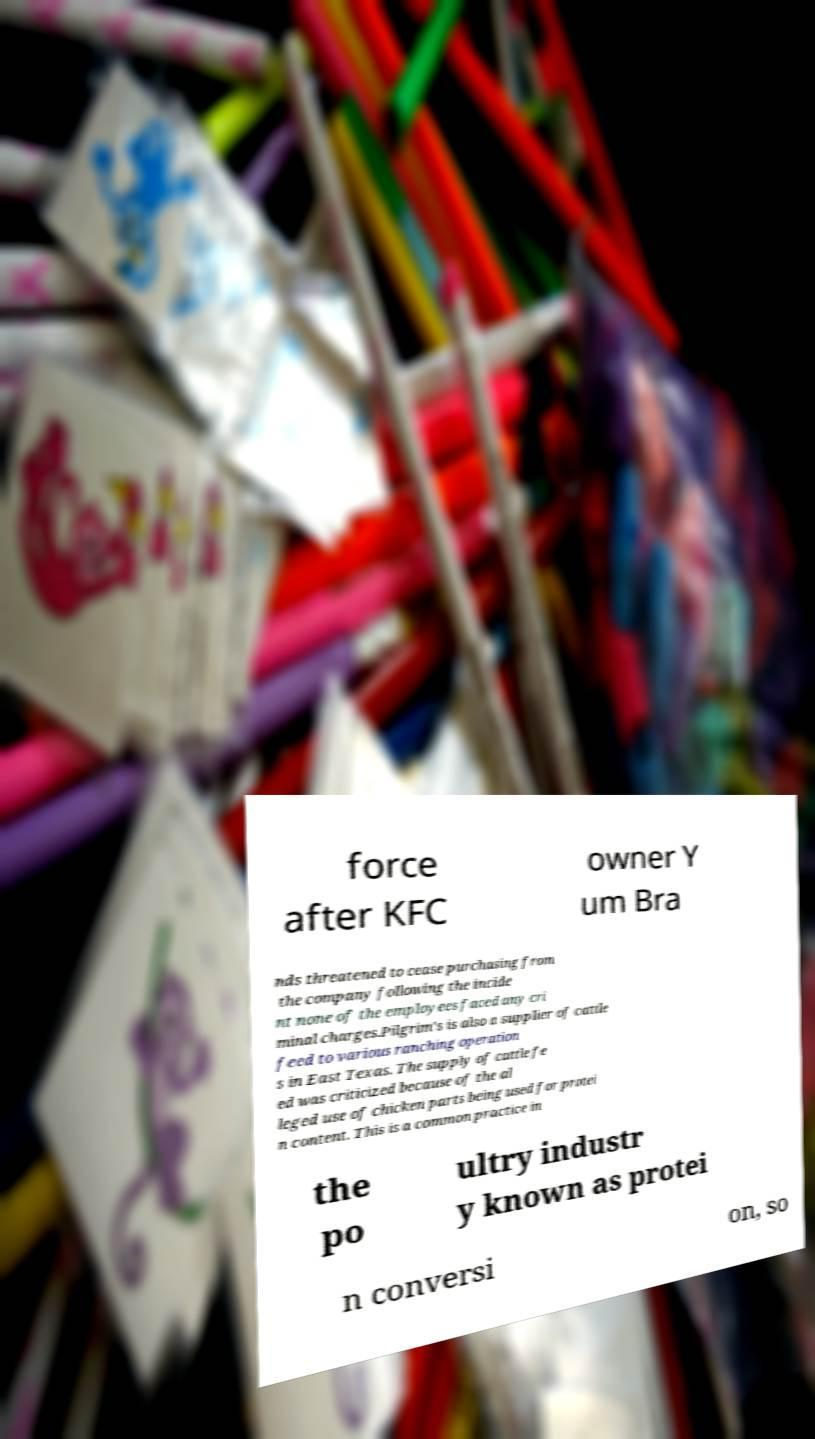Please read and relay the text visible in this image. What does it say? force after KFC owner Y um Bra nds threatened to cease purchasing from the company following the incide nt none of the employees faced any cri minal charges.Pilgrim's is also a supplier of cattle feed to various ranching operation s in East Texas. The supply of cattle fe ed was criticized because of the al leged use of chicken parts being used for protei n content. This is a common practice in the po ultry industr y known as protei n conversi on, so 